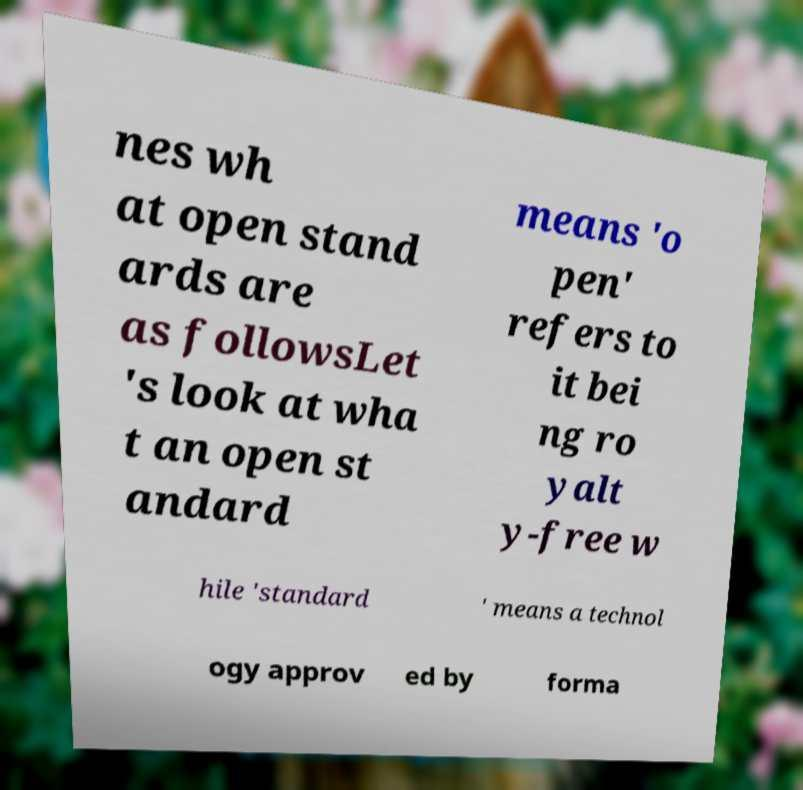What messages or text are displayed in this image? I need them in a readable, typed format. nes wh at open stand ards are as followsLet 's look at wha t an open st andard means 'o pen' refers to it bei ng ro yalt y-free w hile 'standard ' means a technol ogy approv ed by forma 